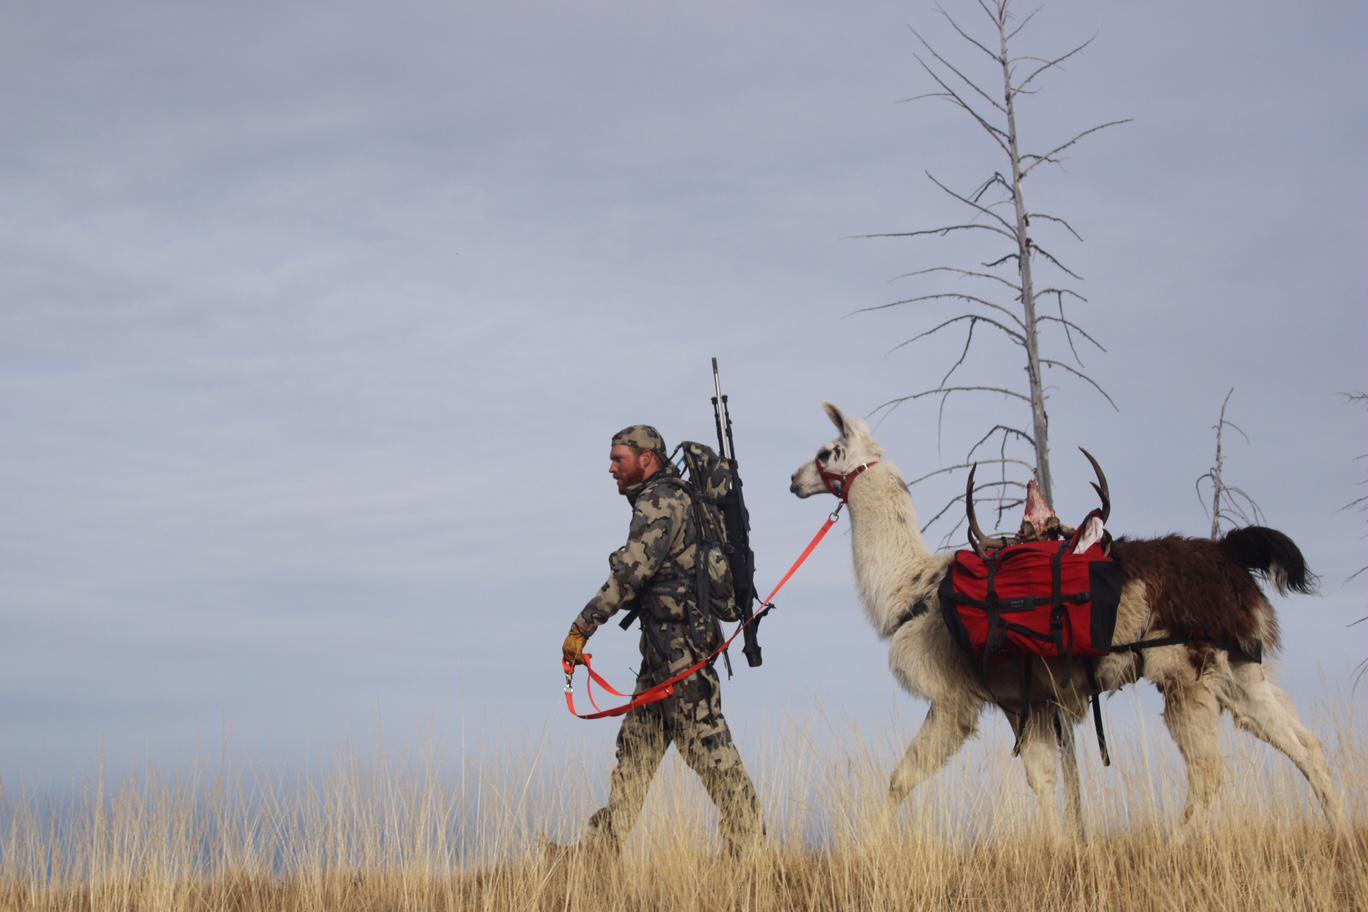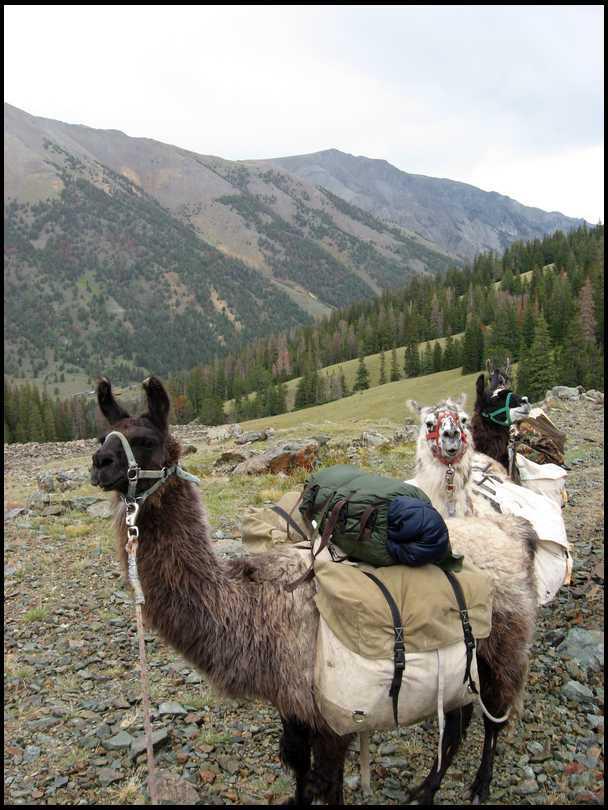The first image is the image on the left, the second image is the image on the right. Evaluate the accuracy of this statement regarding the images: "One man in camo with a bow is leading no more than two packed llamas leftward in one image.". Is it true? Answer yes or no. Yes. The first image is the image on the left, the second image is the image on the right. Evaluate the accuracy of this statement regarding the images: "There are two alpaca in one image and multiple alpacas in the other image.". Is it true? Answer yes or no. No. 